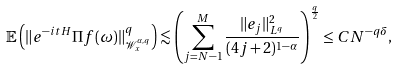Convert formula to latex. <formula><loc_0><loc_0><loc_500><loc_500>\mathbb { E } \left ( \| e ^ { - i t H } \Pi f ( \omega ) \| _ { \mathcal { W } _ { x } ^ { \alpha , q } } ^ { q } \right ) \lesssim \left ( \sum _ { j = N - 1 } ^ { M } \frac { \| e _ { j } \| _ { L ^ { q } } ^ { 2 } } { ( 4 j + 2 ) ^ { 1 - \alpha } } \right ) ^ { \frac { q } { 2 } } \leq C N ^ { - q \delta } ,</formula> 